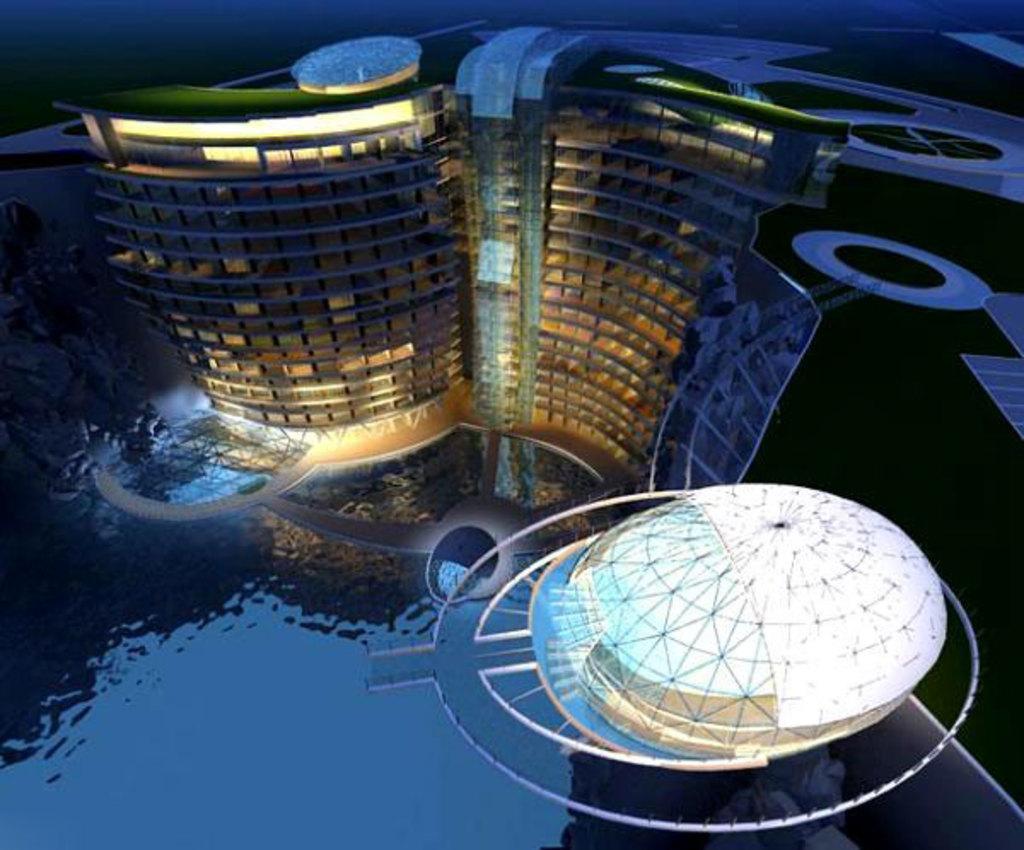Can you describe this image briefly? In this image there is water and architectural buildings. 